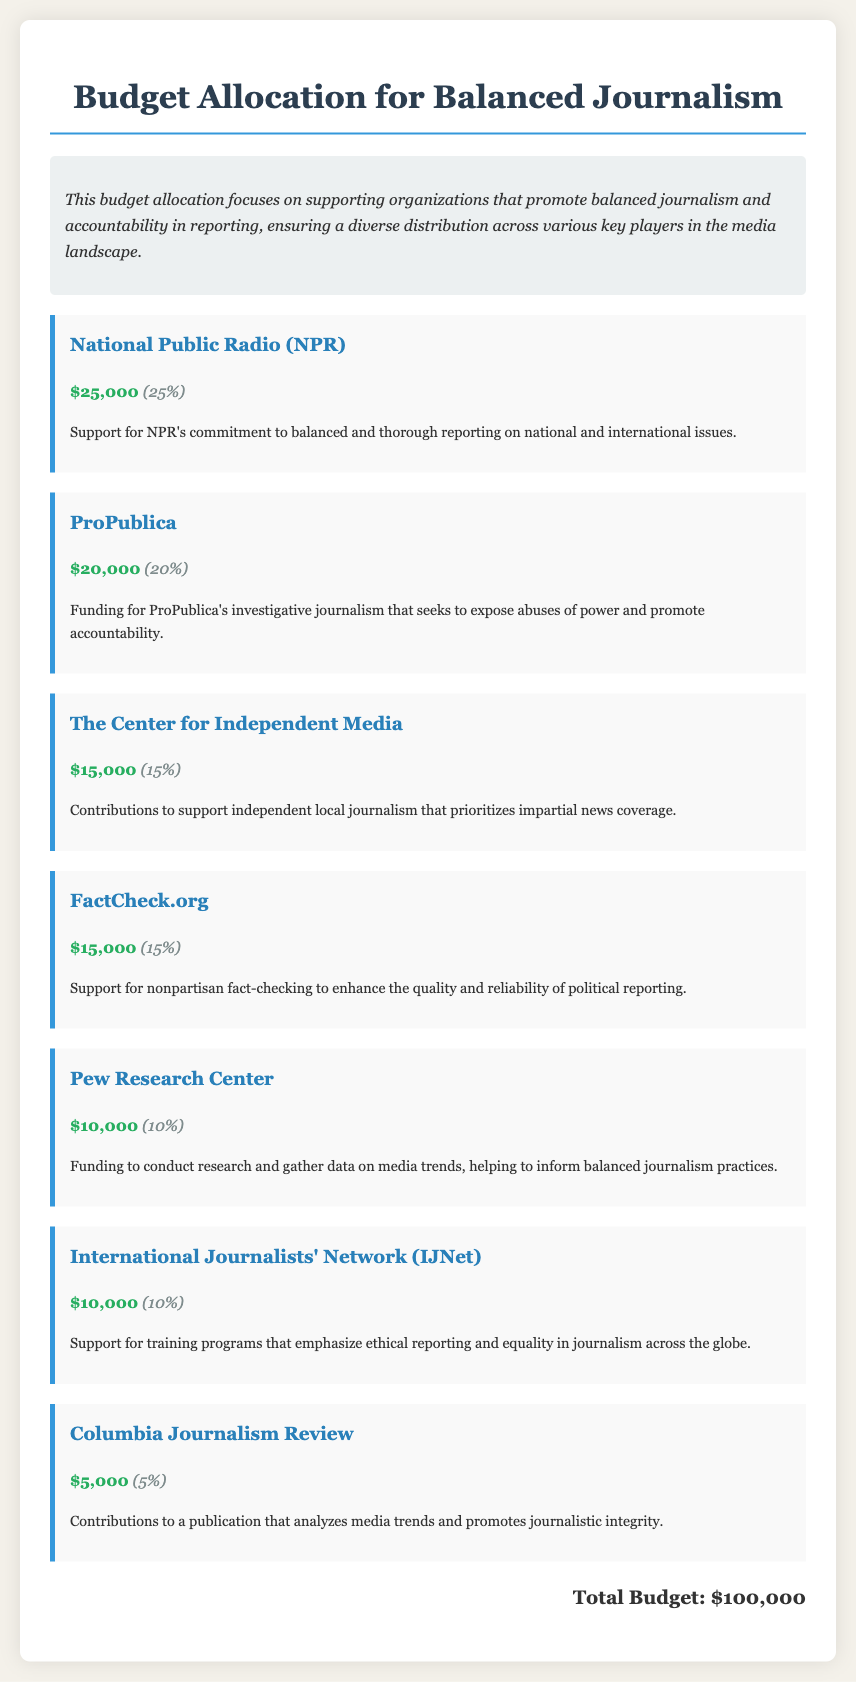What is the total budget? The total budget is stated at the end of the document, summarizing all allocations, which is $100,000.
Answer: $100,000 How much was allocated to National Public Radio? The budget item for National Public Radio indicates a funding amount of $25,000.
Answer: $25,000 What percentage of the budget is allocated to ProPublica? The document specifies that ProPublica receives 20% of the budget.
Answer: 20% Which organization received the least funding? By looking at the budget allocations, Columbia Journalism Review received the smallest amount with $5,000.
Answer: Columbia Journalism Review What is the purpose of the funding for FactCheck.org? The description for FactCheck.org outlines its role in providing nonpartisan fact-checking to enhance reporting.
Answer: Nonpartisan fact-checking How much funding does Pew Research Center receive? The budget allocation directly states that Pew Research Center is allocated $10,000.
Answer: $10,000 Which two organizations received the same amount of funding? The allocations for The Center for Independent Media and FactCheck.org are both $15,000.
Answer: The Center for Independent Media and FactCheck.org What is the main focus of the budget allocation? The summary section of the document clearly states that the budget focuses on supporting balanced journalism.
Answer: Supporting balanced journalism 